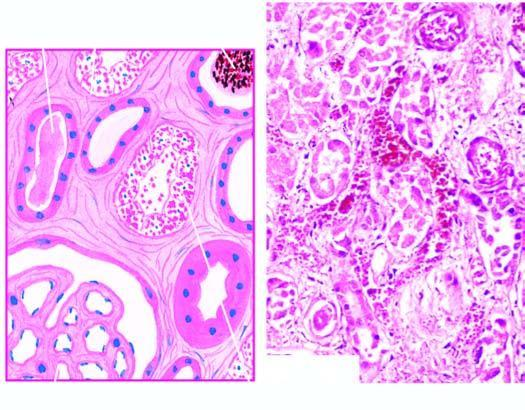what do their lumina contain?
Answer the question using a single word or phrase. Casts 